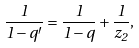<formula> <loc_0><loc_0><loc_500><loc_500>\frac { 1 } { 1 - q ^ { \prime } } = \frac { 1 } { 1 - q } + \frac { 1 } { z _ { 2 } } ,</formula> 